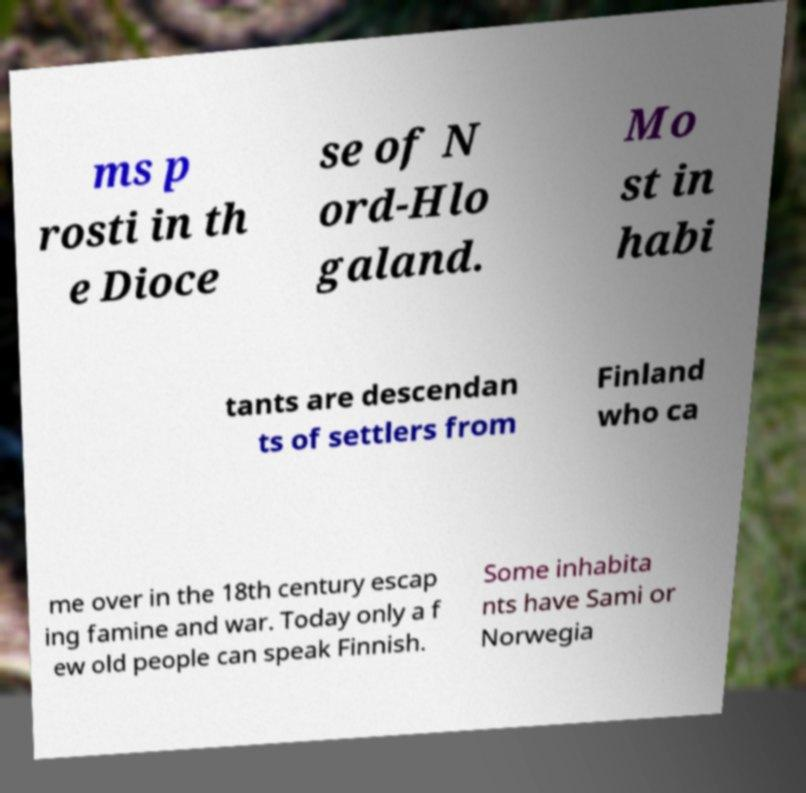For documentation purposes, I need the text within this image transcribed. Could you provide that? ms p rosti in th e Dioce se of N ord-Hlo galand. Mo st in habi tants are descendan ts of settlers from Finland who ca me over in the 18th century escap ing famine and war. Today only a f ew old people can speak Finnish. Some inhabita nts have Sami or Norwegia 